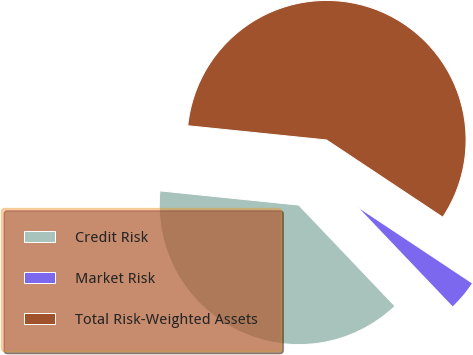<chart> <loc_0><loc_0><loc_500><loc_500><pie_chart><fcel>Credit Risk<fcel>Market Risk<fcel>Total Risk-Weighted Assets<nl><fcel>38.74%<fcel>3.55%<fcel>57.71%<nl></chart> 